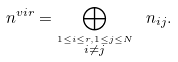Convert formula to latex. <formula><loc_0><loc_0><loc_500><loc_500>\ n ^ { v i r } = \bigoplus _ { \stackrel { 1 \leq i \leq r , 1 \leq j \leq N } { i \neq j } } \ n _ { i j } .</formula> 